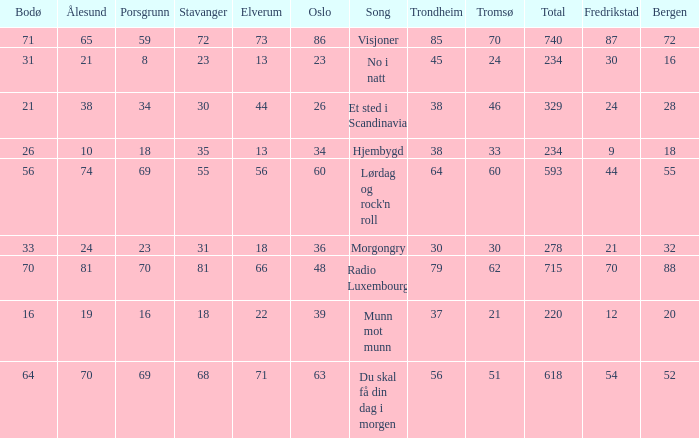What was the total for radio luxembourg? 715.0. 